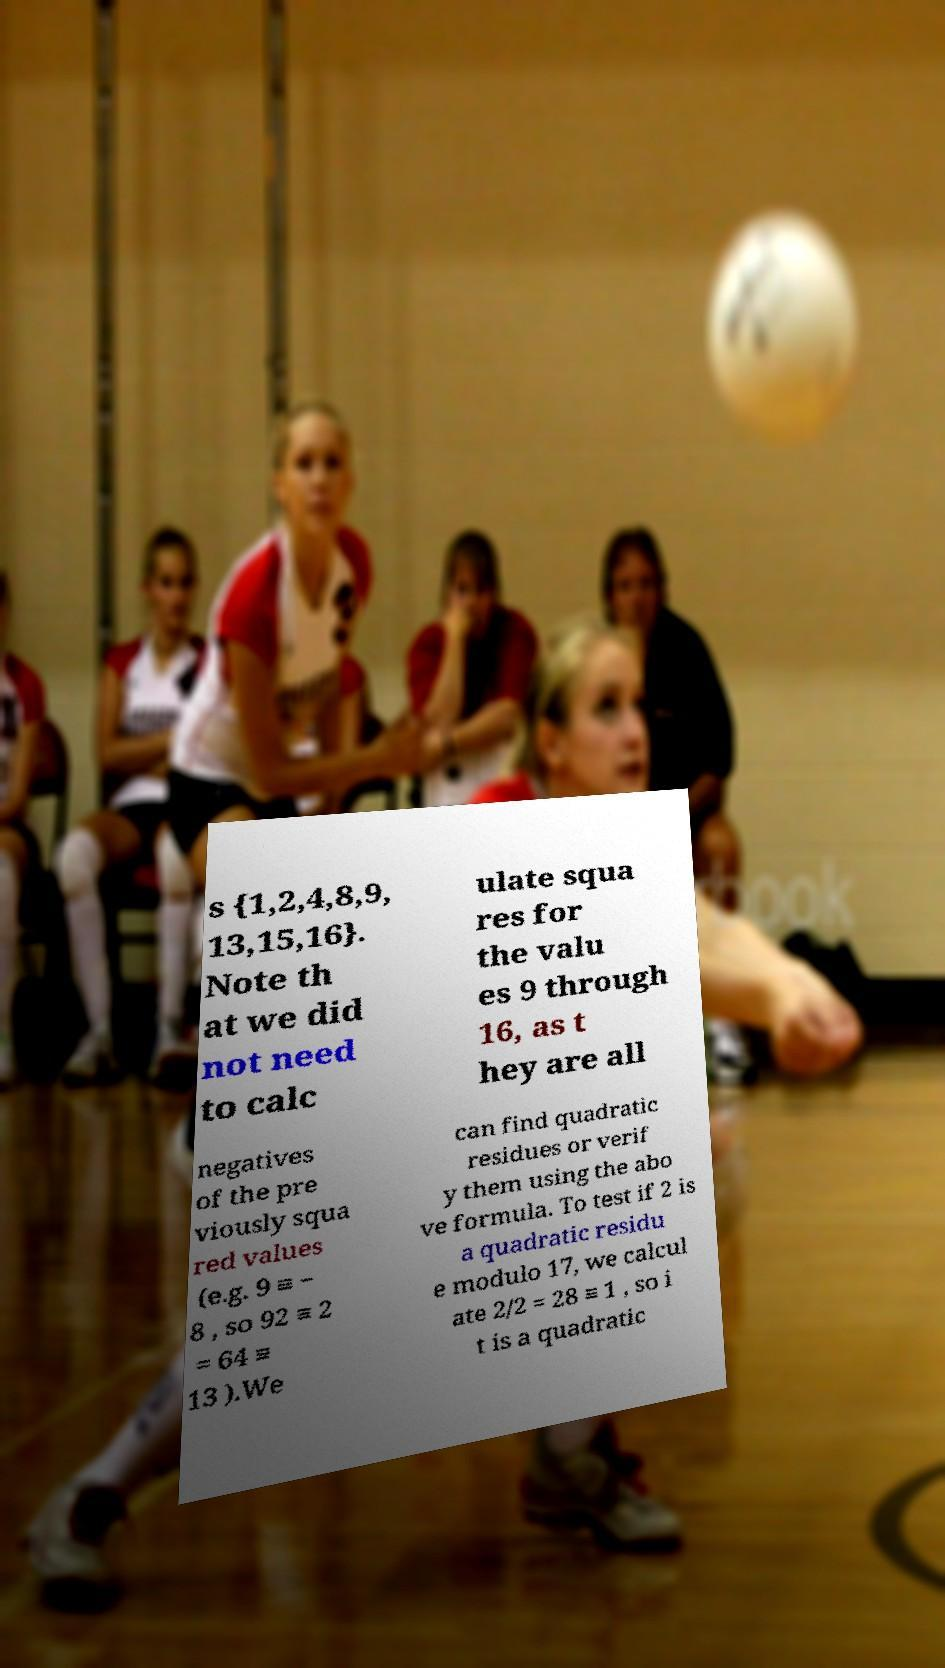Could you assist in decoding the text presented in this image and type it out clearly? s {1,2,4,8,9, 13,15,16}. Note th at we did not need to calc ulate squa res for the valu es 9 through 16, as t hey are all negatives of the pre viously squa red values (e.g. 9 ≡ − 8 , so 92 ≡ 2 = 64 ≡ 13 ).We can find quadratic residues or verif y them using the abo ve formula. To test if 2 is a quadratic residu e modulo 17, we calcul ate 2/2 = 28 ≡ 1 , so i t is a quadratic 